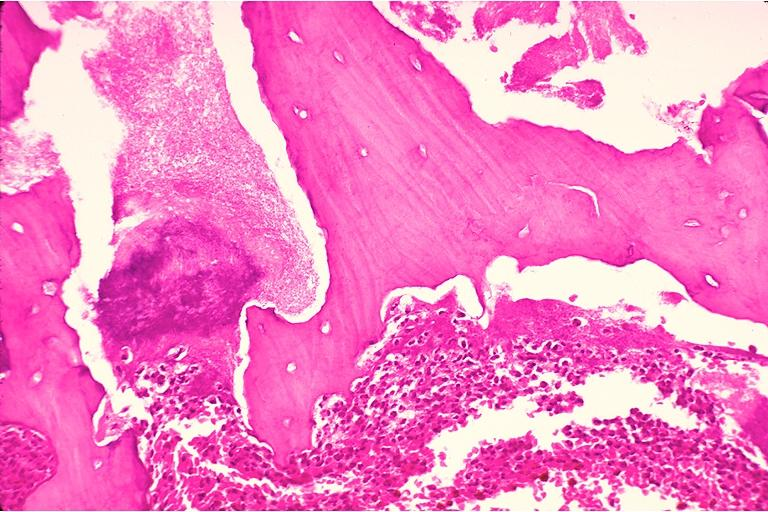what is present?
Answer the question using a single word or phrase. Oral 